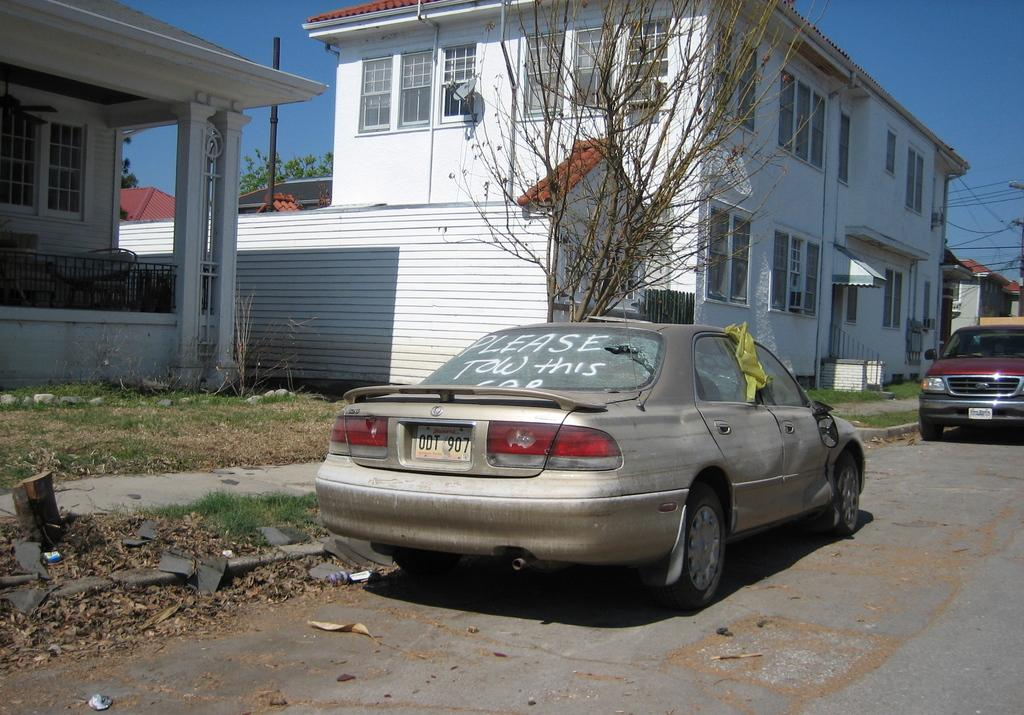What can be seen on the road in the image? There are cars parked on the road in the image. What type of surface is the ground covered with? The ground is covered with grass. What type of vegetation is present in the image? There are trees in the image. What type of structures can be seen in the image? There are buildings in the image. What is the condition of the sky in the image? The sky is clear in the image. Can you tell me how many poisonous snakes are crawling on the grass in the image? There are no poisonous snakes present in the image; the ground is covered with grass. What type of flight is taking place in the image? There is no flight depicted in the image; it features cars parked on the road, trees, buildings, and a clear sky. 